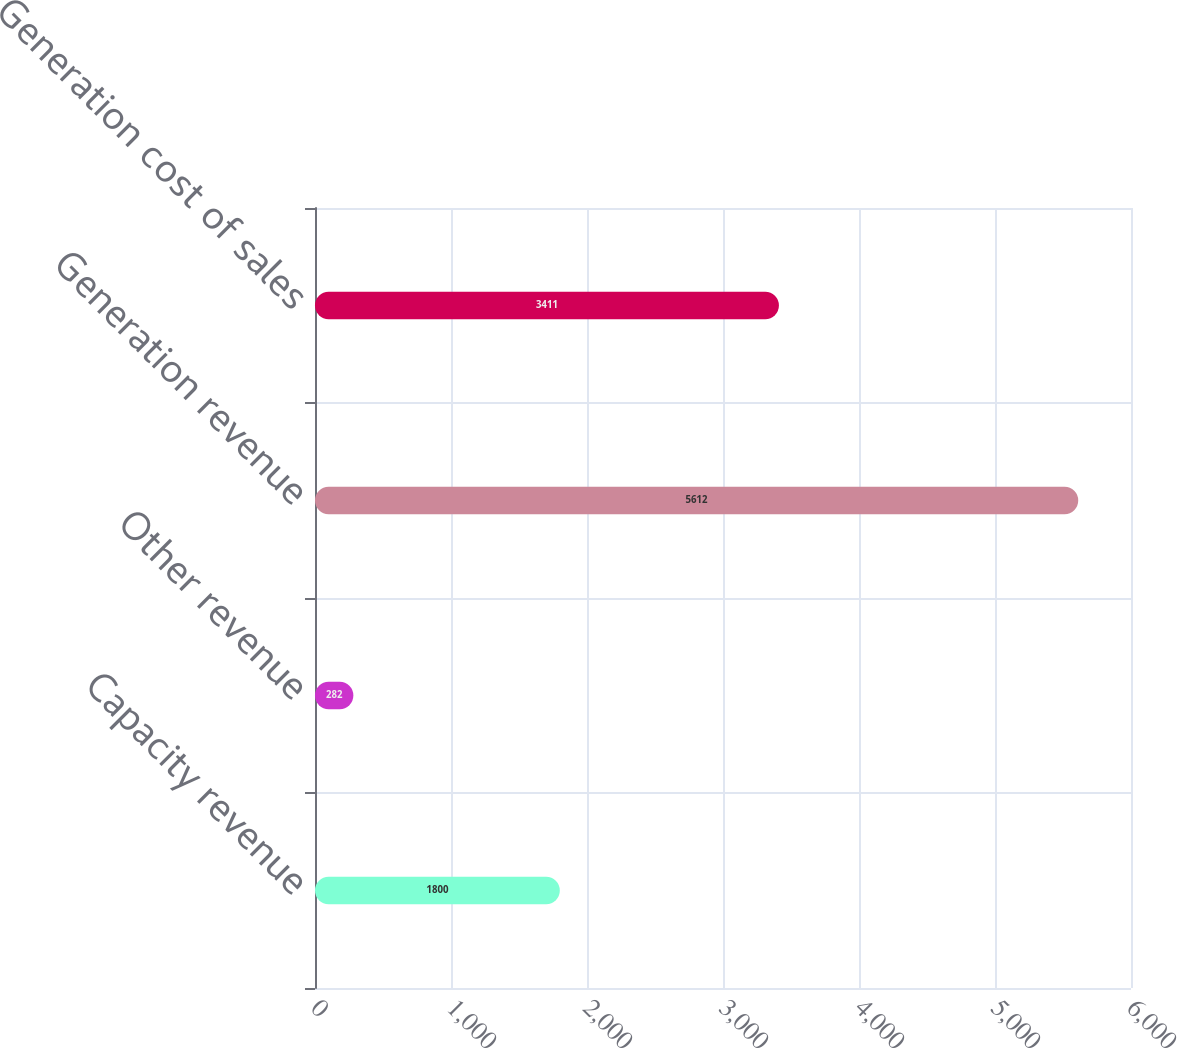Convert chart. <chart><loc_0><loc_0><loc_500><loc_500><bar_chart><fcel>Capacity revenue<fcel>Other revenue<fcel>Generation revenue<fcel>Generation cost of sales<nl><fcel>1800<fcel>282<fcel>5612<fcel>3411<nl></chart> 